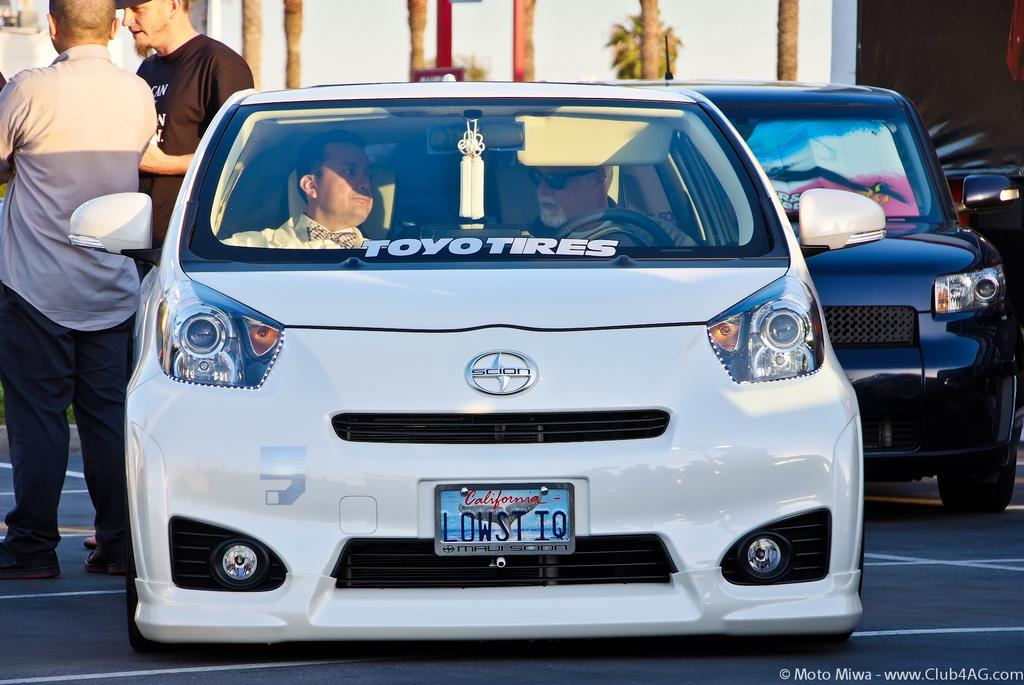What can be seen on the road in the image? There are two cars on the road in the image. Are there any people visible in the image? Yes, there are two people standing on the left side of the image. What type of dress is the achiever wearing in the image? There is no achiever or dress present in the image. What order are the cars driving in the image? The provided facts do not specify the order in which the cars are driving. 